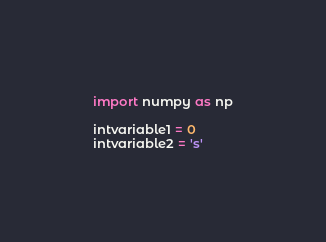Convert code to text. <code><loc_0><loc_0><loc_500><loc_500><_Python_>import numpy as np

intvariable1 = 0
intvariable2 = 's'
</code> 